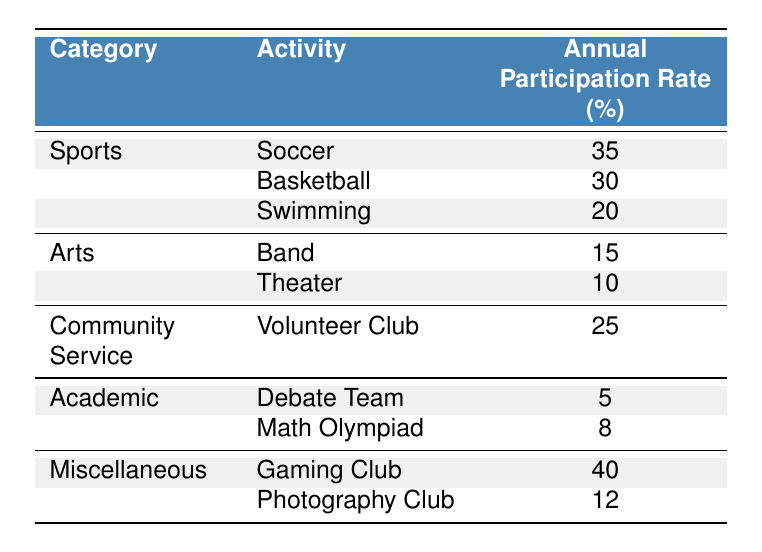What is the annual participation rate for the Soccer activity? The table clearly lists the participation rates for each activity, and for Soccer, it states the rate is 35%.
Answer: 35% Which activity in the Sports category has the lowest annual participation rate? Looking at the Sports category, Swimming has a participation rate of 20%, which is lower than Soccer (35%) and Basketball (30%).
Answer: Swimming What is the total annual participation rate for all activities in the Arts category? The Arts category includes Band (15%) and Theater (10%). Adding these together gives 15 + 10 = 25%.
Answer: 25% Is the annual participation rate for the Gaming Club higher than that of the Volunteer Club? The Gaming Club has a participation rate of 40%, while the Volunteer Club has a rate of 25%. Since 40% is greater than 25%, the statement is true.
Answer: Yes What is the average annual participation rate for all activities listed in the table? To find the average, first sum the participation rates: 35 + 30 + 20 + 15 + 10 + 25 + 5 + 8 + 40 + 12 =  155. There are 10 activities, so the average is 155 / 10 = 15.5%.
Answer: 15.5% How many activities have an annual participation rate of less than 10%? The table shows two activities: the Debate Team (5%) and the Math Olympiad (8%), both of which have rates below 10%. Thus, there are 2 activities.
Answer: 2 What is the difference in annual participation rates between the Gaming Club and the Debate Team? The Gaming Club's rate is 40% while the Debate Team's rate is 5%. The difference is calculated as 40 - 5 = 35%.
Answer: 35% Which category has the highest participation rate of any activity listed? Reviewing the categories, Miscellaneous has the Gaming Club at 40%, which is higher than any activity in the other categories (Sports, Arts, Community Service, and Academic). Hence, the highest participation rate category is Miscellaneous with the Gaming Club.
Answer: Miscellaneous (Gaming Club) 